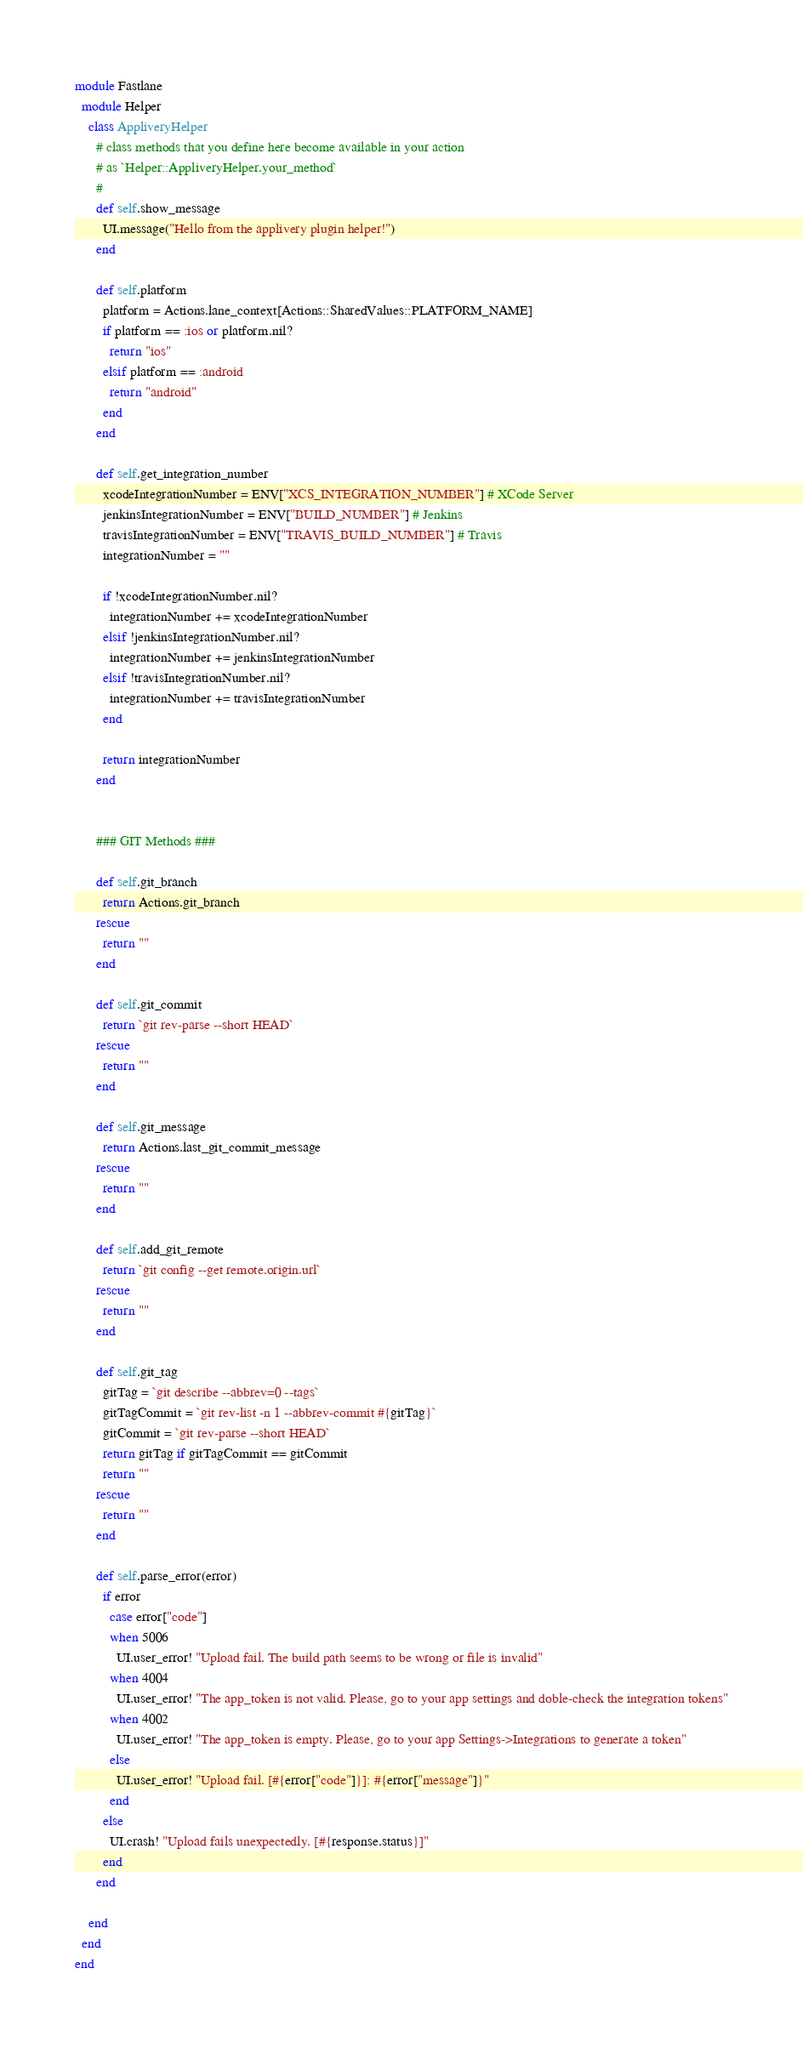Convert code to text. <code><loc_0><loc_0><loc_500><loc_500><_Ruby_>module Fastlane
  module Helper
    class AppliveryHelper
      # class methods that you define here become available in your action
      # as `Helper::AppliveryHelper.your_method`
      #
      def self.show_message
        UI.message("Hello from the applivery plugin helper!")
      end

      def self.platform
        platform = Actions.lane_context[Actions::SharedValues::PLATFORM_NAME]
        if platform == :ios or platform.nil?
          return "ios"
        elsif platform == :android
          return "android"
        end
      end

      def self.get_integration_number
        xcodeIntegrationNumber = ENV["XCS_INTEGRATION_NUMBER"] # XCode Server
        jenkinsIntegrationNumber = ENV["BUILD_NUMBER"] # Jenkins
        travisIntegrationNumber = ENV["TRAVIS_BUILD_NUMBER"] # Travis
        integrationNumber = ""
        
        if !xcodeIntegrationNumber.nil?
          integrationNumber += xcodeIntegrationNumber
        elsif !jenkinsIntegrationNumber.nil?
          integrationNumber += jenkinsIntegrationNumber
        elsif !travisIntegrationNumber.nil?
          integrationNumber += travisIntegrationNumber
        end

        return integrationNumber
      end


      ### GIT Methods ###

      def self.git_branch
        return Actions.git_branch
      rescue
        return ""
      end

      def self.git_commit
        return `git rev-parse --short HEAD`
      rescue
        return ""
      end

      def self.git_message
        return Actions.last_git_commit_message
      rescue
        return ""
      end

      def self.add_git_remote
        return `git config --get remote.origin.url`
      rescue
        return ""
      end

      def self.git_tag
        gitTag = `git describe --abbrev=0 --tags`
        gitTagCommit = `git rev-list -n 1 --abbrev-commit #{gitTag}`
        gitCommit = `git rev-parse --short HEAD`
        return gitTag if gitTagCommit == gitCommit
        return ""
      rescue
        return ""
      end

      def self.parse_error(error)
        if error
          case error["code"]
          when 5006
            UI.user_error! "Upload fail. The build path seems to be wrong or file is invalid"
          when 4004
            UI.user_error! "The app_token is not valid. Please, go to your app settings and doble-check the integration tokens"
          when 4002
            UI.user_error! "The app_token is empty. Please, go to your app Settings->Integrations to generate a token"
          else
            UI.user_error! "Upload fail. [#{error["code"]}]: #{error["message"]}"
          end
        else
          UI.crash! "Upload fails unexpectedly. [#{response.status}]"
        end
      end

    end
  end
end
</code> 